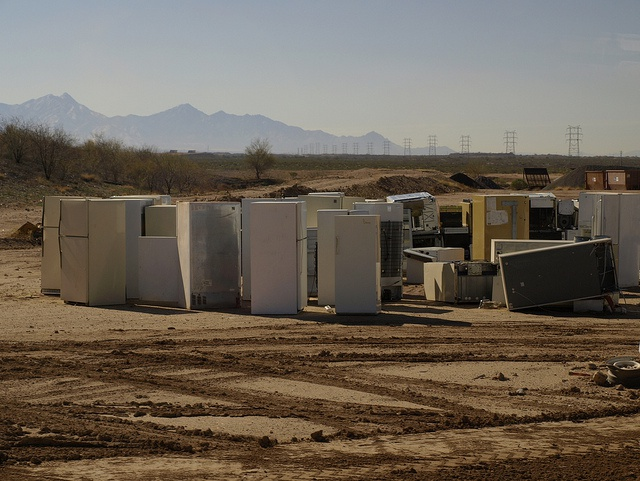Describe the objects in this image and their specific colors. I can see refrigerator in darkgray, black, and gray tones, refrigerator in darkgray, black, gray, and tan tones, refrigerator in darkgray, gray, and black tones, refrigerator in darkgray, gray, and black tones, and refrigerator in darkgray, gray, and black tones in this image. 